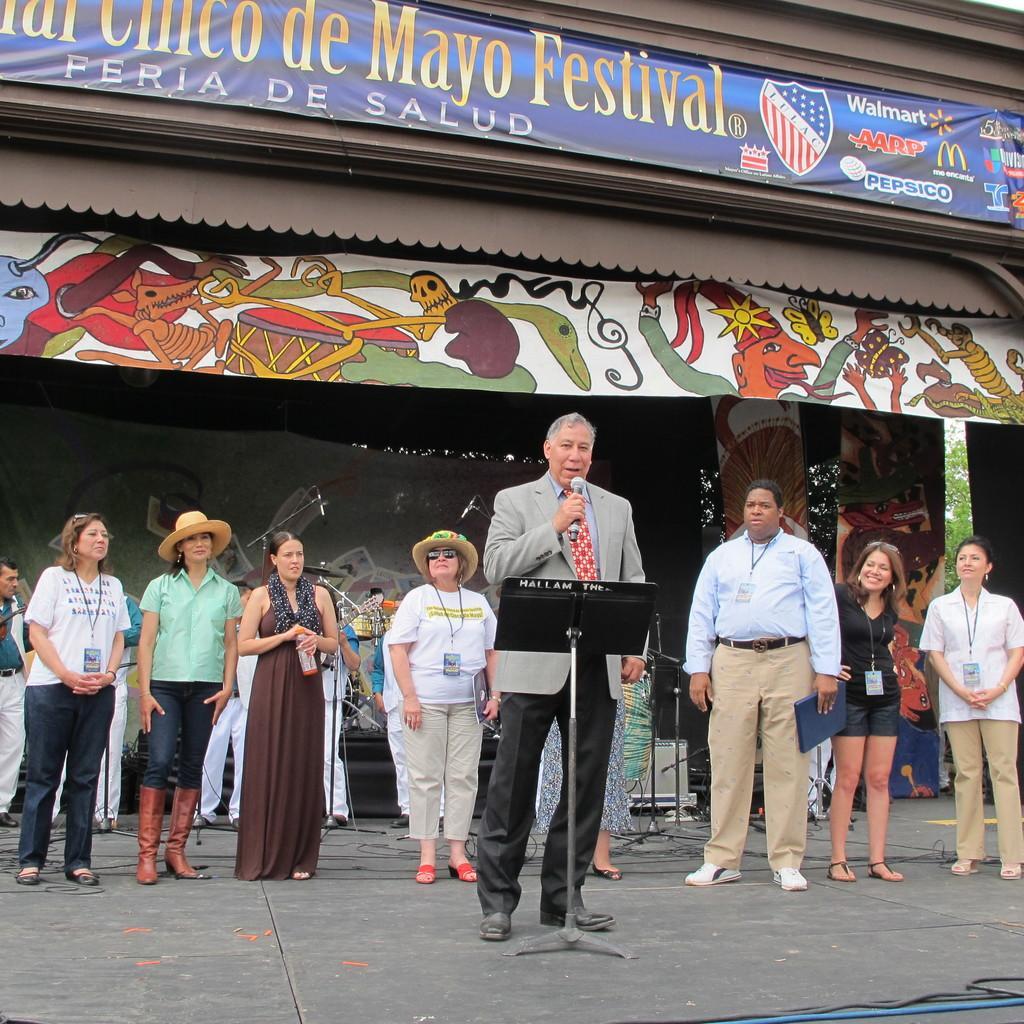Can you describe this image briefly? In this picture we can see a man holding a mic with his hand and in front of him we can see a stand, cables on the floor and at the back of him we can see a group of people standing, banners, mic stands, trees and some objects. 